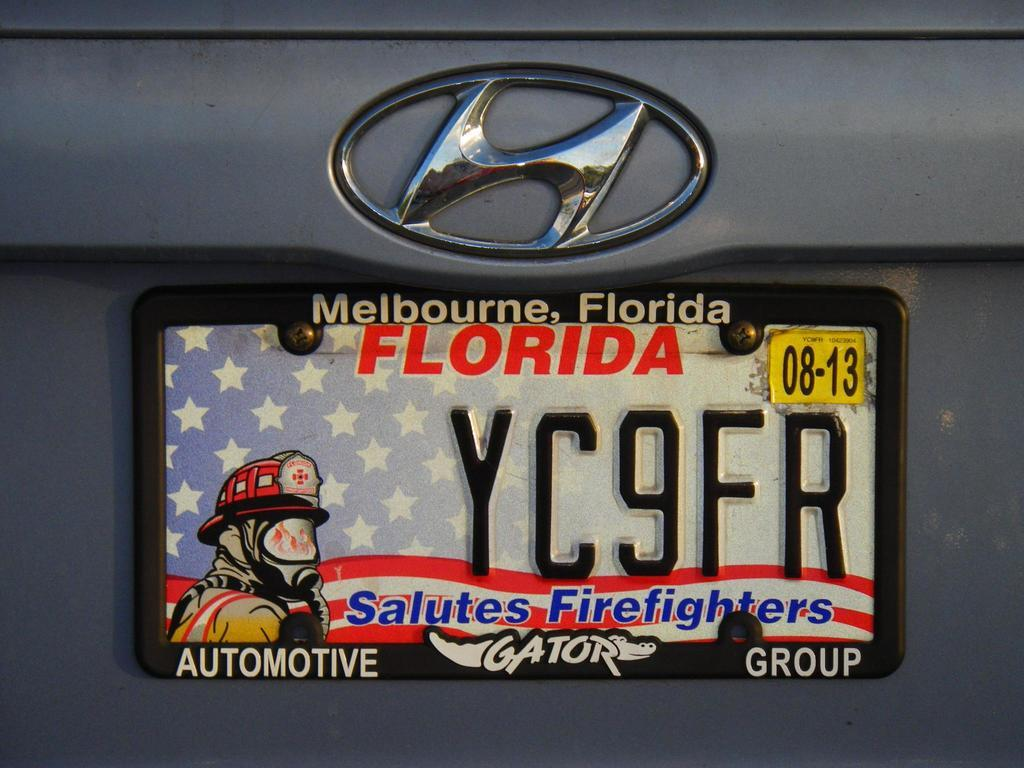<image>
Create a compact narrative representing the image presented. license plate for Florida that salutes American firefighters 